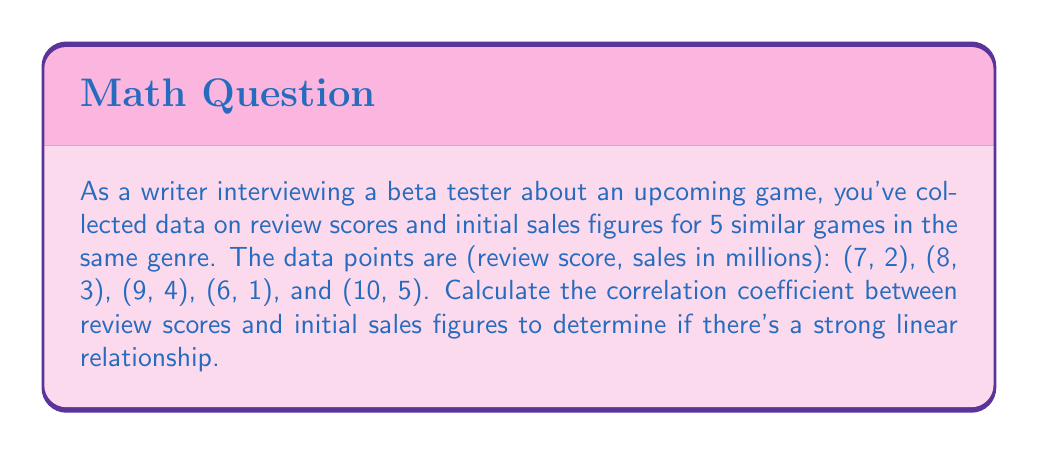Could you help me with this problem? To calculate the correlation coefficient, we'll use the formula:

$$ r = \frac{n\sum xy - \sum x \sum y}{\sqrt{[n\sum x^2 - (\sum x)^2][n\sum y^2 - (\sum y)^2]}} $$

Where:
$n$ = number of data points
$x$ = review scores
$y$ = sales figures in millions

Step 1: Calculate the necessary sums:
$n = 5$
$\sum x = 7 + 8 + 9 + 6 + 10 = 40$
$\sum y = 2 + 3 + 4 + 1 + 5 = 15$
$\sum xy = (7)(2) + (8)(3) + (9)(4) + (6)(1) + (10)(5) = 14 + 24 + 36 + 6 + 50 = 130$
$\sum x^2 = 7^2 + 8^2 + 9^2 + 6^2 + 10^2 = 49 + 64 + 81 + 36 + 100 = 330$
$\sum y^2 = 2^2 + 3^2 + 4^2 + 1^2 + 5^2 = 4 + 9 + 16 + 1 + 25 = 55$

Step 2: Substitute these values into the correlation coefficient formula:

$$ r = \frac{5(130) - (40)(15)}{\sqrt{[5(330) - (40)^2][5(55) - (15)^2]}} $$

Step 3: Simplify:

$$ r = \frac{650 - 600}{\sqrt{(1650 - 1600)(275 - 225)}} = \frac{50}{\sqrt{(50)(50)}} = \frac{50}{50} = 1 $$

The correlation coefficient is 1, indicating a perfect positive linear relationship between review scores and initial sales figures for these games.
Answer: 1 